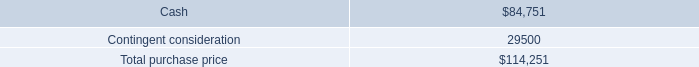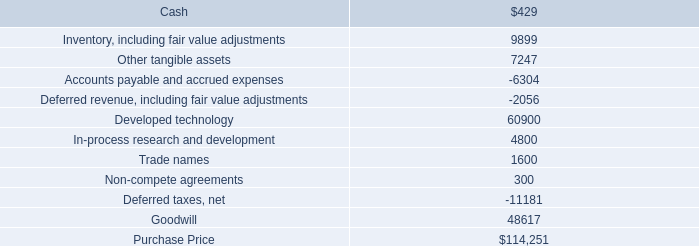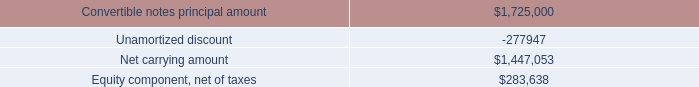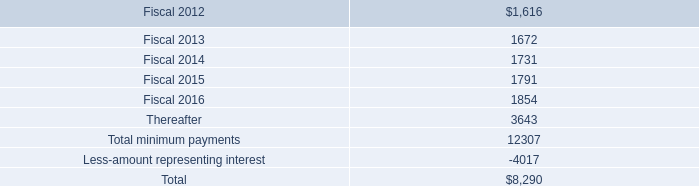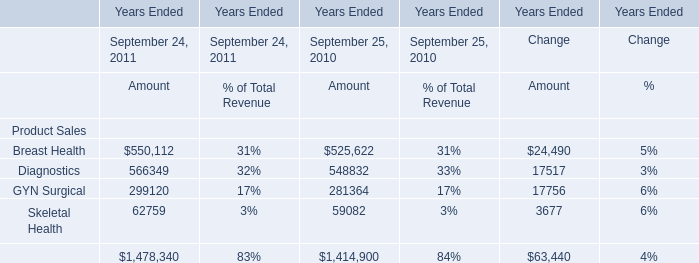What's the average of Equity component, net of taxes, and Accounts payable and accrued expenses ? 
Computations: ((283638.0 + 6304.0) / 2)
Answer: 144971.0. 